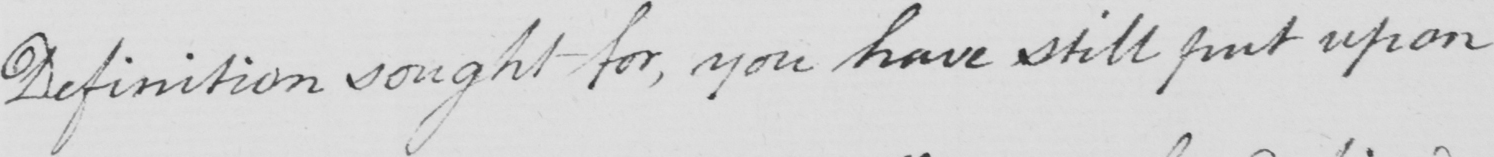Please transcribe the handwritten text in this image. Definition sought for , you have still put upon 